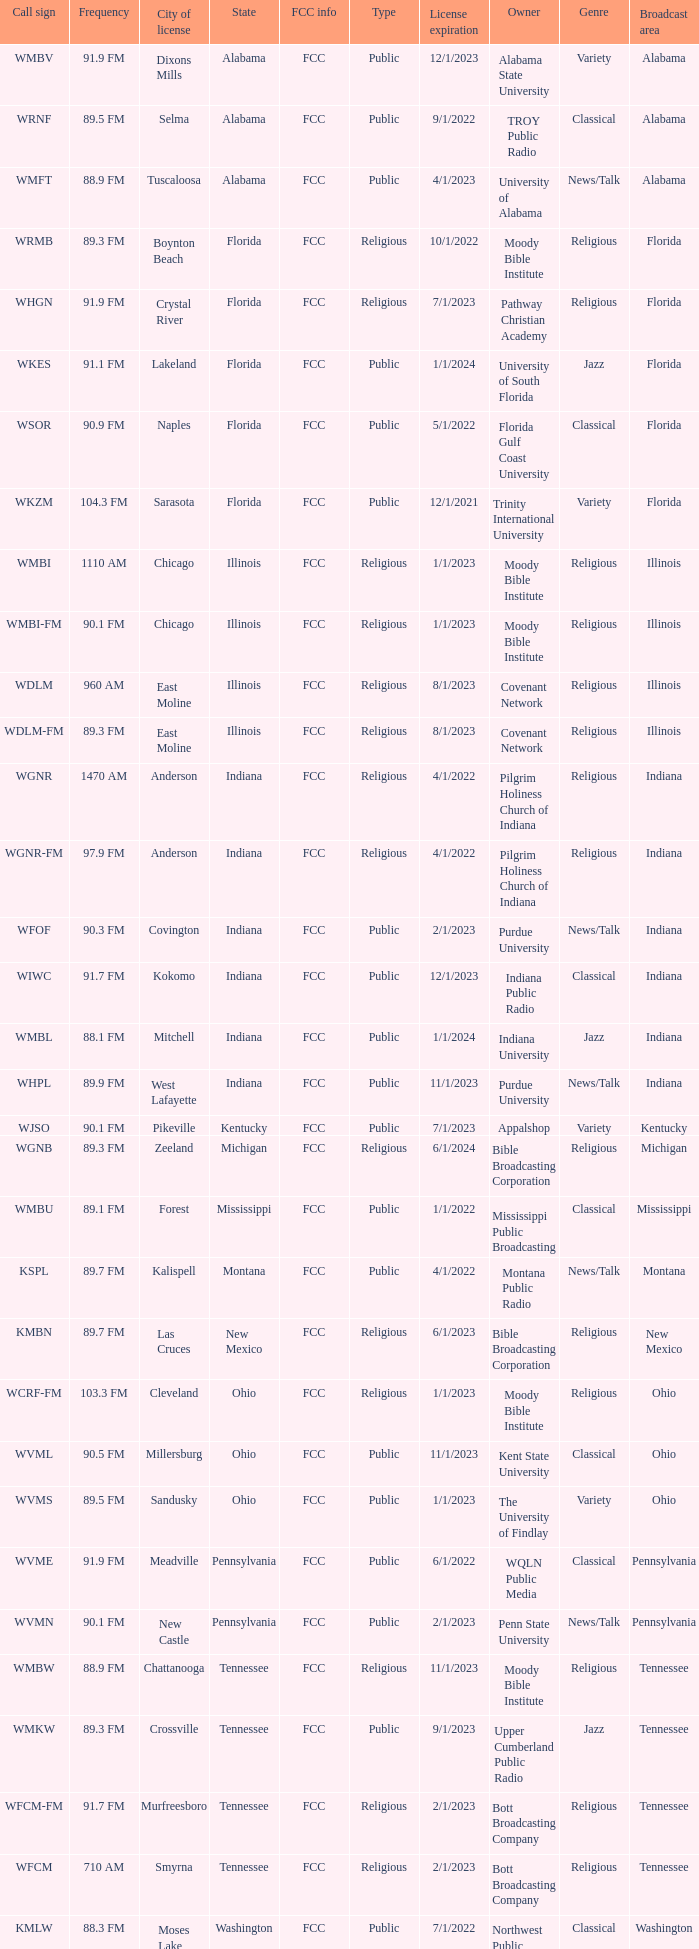I'm looking to parse the entire table for insights. Could you assist me with that? {'header': ['Call sign', 'Frequency', 'City of license', 'State', 'FCC info', 'Type', 'License expiration', 'Owner', 'Genre', 'Broadcast area'], 'rows': [['WMBV', '91.9 FM', 'Dixons Mills', 'Alabama', 'FCC', 'Public', '12/1/2023', 'Alabama State University', 'Variety', 'Alabama'], ['WRNF', '89.5 FM', 'Selma', 'Alabama', 'FCC', 'Public', '9/1/2022', 'TROY Public Radio', 'Classical', 'Alabama'], ['WMFT', '88.9 FM', 'Tuscaloosa', 'Alabama', 'FCC', 'Public', '4/1/2023', 'University of Alabama', 'News/Talk', 'Alabama'], ['WRMB', '89.3 FM', 'Boynton Beach', 'Florida', 'FCC', 'Religious', '10/1/2022', 'Moody Bible Institute', 'Religious', 'Florida'], ['WHGN', '91.9 FM', 'Crystal River', 'Florida', 'FCC', 'Religious', '7/1/2023', 'Pathway Christian Academy', 'Religious', 'Florida'], ['WKES', '91.1 FM', 'Lakeland', 'Florida', 'FCC', 'Public', '1/1/2024', 'University of South Florida', 'Jazz', 'Florida'], ['WSOR', '90.9 FM', 'Naples', 'Florida', 'FCC', 'Public', '5/1/2022', 'Florida Gulf Coast University', 'Classical', 'Florida'], ['WKZM', '104.3 FM', 'Sarasota', 'Florida', 'FCC', 'Public', '12/1/2021', 'Trinity International University', 'Variety', 'Florida'], ['WMBI', '1110 AM', 'Chicago', 'Illinois', 'FCC', 'Religious', '1/1/2023', 'Moody Bible Institute', 'Religious', 'Illinois'], ['WMBI-FM', '90.1 FM', 'Chicago', 'Illinois', 'FCC', 'Religious', '1/1/2023', 'Moody Bible Institute', 'Religious', 'Illinois'], ['WDLM', '960 AM', 'East Moline', 'Illinois', 'FCC', 'Religious', '8/1/2023', 'Covenant Network', 'Religious', 'Illinois'], ['WDLM-FM', '89.3 FM', 'East Moline', 'Illinois', 'FCC', 'Religious', '8/1/2023', 'Covenant Network', 'Religious', 'Illinois'], ['WGNR', '1470 AM', 'Anderson', 'Indiana', 'FCC', 'Religious', '4/1/2022', 'Pilgrim Holiness Church of Indiana', 'Religious', 'Indiana'], ['WGNR-FM', '97.9 FM', 'Anderson', 'Indiana', 'FCC', 'Religious', '4/1/2022', 'Pilgrim Holiness Church of Indiana', 'Religious', 'Indiana'], ['WFOF', '90.3 FM', 'Covington', 'Indiana', 'FCC', 'Public', '2/1/2023', 'Purdue University', 'News/Talk', 'Indiana'], ['WIWC', '91.7 FM', 'Kokomo', 'Indiana', 'FCC', 'Public', '12/1/2023', 'Indiana Public Radio', 'Classical', 'Indiana'], ['WMBL', '88.1 FM', 'Mitchell', 'Indiana', 'FCC', 'Public', '1/1/2024', 'Indiana University', 'Jazz', 'Indiana'], ['WHPL', '89.9 FM', 'West Lafayette', 'Indiana', 'FCC', 'Public', '11/1/2023', 'Purdue University', 'News/Talk', 'Indiana'], ['WJSO', '90.1 FM', 'Pikeville', 'Kentucky', 'FCC', 'Public', '7/1/2023', 'Appalshop', 'Variety', 'Kentucky'], ['WGNB', '89.3 FM', 'Zeeland', 'Michigan', 'FCC', 'Religious', '6/1/2024', 'Bible Broadcasting Corporation', 'Religious', 'Michigan'], ['WMBU', '89.1 FM', 'Forest', 'Mississippi', 'FCC', 'Public', '1/1/2022', 'Mississippi Public Broadcasting', 'Classical', 'Mississippi'], ['KSPL', '89.7 FM', 'Kalispell', 'Montana', 'FCC', 'Public', '4/1/2022', 'Montana Public Radio', 'News/Talk', 'Montana'], ['KMBN', '89.7 FM', 'Las Cruces', 'New Mexico', 'FCC', 'Religious', '6/1/2023', 'Bible Broadcasting Corporation', 'Religious', 'New Mexico'], ['WCRF-FM', '103.3 FM', 'Cleveland', 'Ohio', 'FCC', 'Religious', '1/1/2023', 'Moody Bible Institute', 'Religious', 'Ohio'], ['WVML', '90.5 FM', 'Millersburg', 'Ohio', 'FCC', 'Public', '11/1/2023', 'Kent State University', 'Classical', 'Ohio'], ['WVMS', '89.5 FM', 'Sandusky', 'Ohio', 'FCC', 'Public', '1/1/2023', 'The University of Findlay', 'Variety', 'Ohio'], ['WVME', '91.9 FM', 'Meadville', 'Pennsylvania', 'FCC', 'Public', '6/1/2022', 'WQLN Public Media', 'Classical', 'Pennsylvania'], ['WVMN', '90.1 FM', 'New Castle', 'Pennsylvania', 'FCC', 'Public', '2/1/2023', 'Penn State University', 'News/Talk', 'Pennsylvania'], ['WMBW', '88.9 FM', 'Chattanooga', 'Tennessee', 'FCC', 'Religious', '11/1/2023', 'Moody Bible Institute', 'Religious', 'Tennessee'], ['WMKW', '89.3 FM', 'Crossville', 'Tennessee', 'FCC', 'Public', '9/1/2023', 'Upper Cumberland Public Radio', 'Jazz', 'Tennessee'], ['WFCM-FM', '91.7 FM', 'Murfreesboro', 'Tennessee', 'FCC', 'Religious', '2/1/2023', 'Bott Broadcasting Company', 'Religious', 'Tennessee'], ['WFCM', '710 AM', 'Smyrna', 'Tennessee', 'FCC', 'Religious', '2/1/2023', 'Bott Broadcasting Company', 'Religious', 'Tennessee'], ['KMLW', '88.3 FM', 'Moses Lake', 'Washington', 'FCC', 'Public', '7/1/2022', 'Northwest Public Broadcasting', 'Classical', 'Washington'], ['KMBI', '1330 AM', 'Spokane', 'Washington', 'FCC', 'Religious', '8/1/2023', 'Moody Bible Institute', 'Religious', 'Washington'], ['KMBI-FM', '107.9 FM', 'Spokane', 'Washington', 'FCC', 'Religious', '8/1/2023', 'Moody Bible Institute', 'Religious', 'Washington'], ['KMWY', '91.1 FM', 'Jackson', 'Wyoming', 'FCC', 'Public', '1/1/2023', 'Wyoming Public Media', 'News/Talk', 'Wyoming']]} What is the call sign for 90.9 FM which is in Florida? WSOR. 